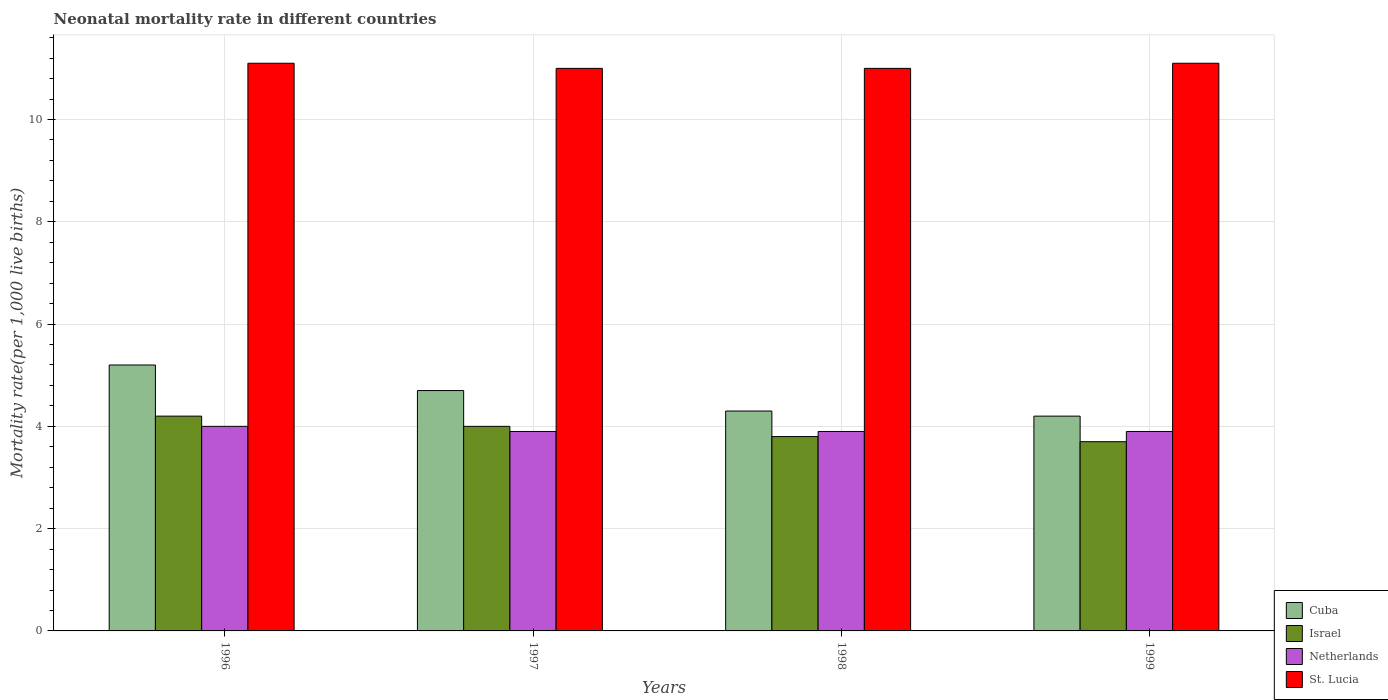How many different coloured bars are there?
Provide a succinct answer. 4. Are the number of bars per tick equal to the number of legend labels?
Keep it short and to the point. Yes. How many bars are there on the 4th tick from the right?
Your answer should be compact. 4. What is the label of the 3rd group of bars from the left?
Your answer should be compact. 1998. In how many cases, is the number of bars for a given year not equal to the number of legend labels?
Make the answer very short. 0. What is the neonatal mortality rate in Netherlands in 1996?
Offer a terse response. 4. Across all years, what is the maximum neonatal mortality rate in St. Lucia?
Your answer should be compact. 11.1. What is the total neonatal mortality rate in Cuba in the graph?
Offer a very short reply. 18.4. What is the difference between the neonatal mortality rate in Netherlands in 1996 and that in 1997?
Give a very brief answer. 0.1. What is the difference between the neonatal mortality rate in Netherlands in 1997 and the neonatal mortality rate in Israel in 1996?
Offer a terse response. -0.3. What is the average neonatal mortality rate in St. Lucia per year?
Your answer should be very brief. 11.05. In the year 1998, what is the difference between the neonatal mortality rate in St. Lucia and neonatal mortality rate in Cuba?
Make the answer very short. 6.7. In how many years, is the neonatal mortality rate in Cuba greater than 6.4?
Offer a very short reply. 0. What is the ratio of the neonatal mortality rate in St. Lucia in 1996 to that in 1999?
Keep it short and to the point. 1. Is the neonatal mortality rate in Cuba in 1997 less than that in 1998?
Your answer should be compact. No. What is the difference between the highest and the second highest neonatal mortality rate in Cuba?
Your answer should be very brief. 0.5. What is the difference between the highest and the lowest neonatal mortality rate in Cuba?
Offer a very short reply. 1. In how many years, is the neonatal mortality rate in Netherlands greater than the average neonatal mortality rate in Netherlands taken over all years?
Give a very brief answer. 1. Is the sum of the neonatal mortality rate in Cuba in 1997 and 1998 greater than the maximum neonatal mortality rate in Netherlands across all years?
Your answer should be very brief. Yes. What does the 4th bar from the left in 1998 represents?
Your response must be concise. St. Lucia. What does the 4th bar from the right in 1999 represents?
Provide a succinct answer. Cuba. Is it the case that in every year, the sum of the neonatal mortality rate in Israel and neonatal mortality rate in Cuba is greater than the neonatal mortality rate in Netherlands?
Give a very brief answer. Yes. What is the difference between two consecutive major ticks on the Y-axis?
Provide a succinct answer. 2. Does the graph contain any zero values?
Provide a short and direct response. No. Where does the legend appear in the graph?
Offer a very short reply. Bottom right. What is the title of the graph?
Provide a succinct answer. Neonatal mortality rate in different countries. Does "Singapore" appear as one of the legend labels in the graph?
Make the answer very short. No. What is the label or title of the Y-axis?
Give a very brief answer. Mortality rate(per 1,0 live births). What is the Mortality rate(per 1,000 live births) of Netherlands in 1996?
Offer a very short reply. 4. What is the Mortality rate(per 1,000 live births) of St. Lucia in 1996?
Give a very brief answer. 11.1. What is the Mortality rate(per 1,000 live births) of Cuba in 1997?
Offer a very short reply. 4.7. What is the Mortality rate(per 1,000 live births) in Israel in 1997?
Offer a terse response. 4. What is the Mortality rate(per 1,000 live births) of St. Lucia in 1997?
Offer a very short reply. 11. What is the Mortality rate(per 1,000 live births) in Cuba in 1998?
Offer a terse response. 4.3. What is the Mortality rate(per 1,000 live births) of Israel in 1998?
Provide a short and direct response. 3.8. What is the Mortality rate(per 1,000 live births) of Netherlands in 1998?
Offer a very short reply. 3.9. What is the Mortality rate(per 1,000 live births) of St. Lucia in 1998?
Your response must be concise. 11. What is the Mortality rate(per 1,000 live births) of Cuba in 1999?
Make the answer very short. 4.2. What is the Mortality rate(per 1,000 live births) in St. Lucia in 1999?
Make the answer very short. 11.1. Across all years, what is the maximum Mortality rate(per 1,000 live births) in Cuba?
Offer a terse response. 5.2. Across all years, what is the minimum Mortality rate(per 1,000 live births) in Cuba?
Provide a short and direct response. 4.2. Across all years, what is the minimum Mortality rate(per 1,000 live births) in Netherlands?
Your answer should be very brief. 3.9. Across all years, what is the minimum Mortality rate(per 1,000 live births) of St. Lucia?
Provide a succinct answer. 11. What is the total Mortality rate(per 1,000 live births) of Cuba in the graph?
Make the answer very short. 18.4. What is the total Mortality rate(per 1,000 live births) of Israel in the graph?
Your response must be concise. 15.7. What is the total Mortality rate(per 1,000 live births) of Netherlands in the graph?
Your answer should be compact. 15.7. What is the total Mortality rate(per 1,000 live births) in St. Lucia in the graph?
Make the answer very short. 44.2. What is the difference between the Mortality rate(per 1,000 live births) in Netherlands in 1996 and that in 1997?
Offer a terse response. 0.1. What is the difference between the Mortality rate(per 1,000 live births) in Cuba in 1996 and that in 1998?
Your response must be concise. 0.9. What is the difference between the Mortality rate(per 1,000 live births) in Israel in 1996 and that in 1998?
Give a very brief answer. 0.4. What is the difference between the Mortality rate(per 1,000 live births) of Netherlands in 1996 and that in 1998?
Provide a short and direct response. 0.1. What is the difference between the Mortality rate(per 1,000 live births) in St. Lucia in 1996 and that in 1998?
Provide a short and direct response. 0.1. What is the difference between the Mortality rate(per 1,000 live births) of Cuba in 1996 and that in 1999?
Offer a very short reply. 1. What is the difference between the Mortality rate(per 1,000 live births) of Netherlands in 1996 and that in 1999?
Make the answer very short. 0.1. What is the difference between the Mortality rate(per 1,000 live births) in St. Lucia in 1996 and that in 1999?
Ensure brevity in your answer.  0. What is the difference between the Mortality rate(per 1,000 live births) in Cuba in 1997 and that in 1998?
Keep it short and to the point. 0.4. What is the difference between the Mortality rate(per 1,000 live births) in St. Lucia in 1997 and that in 1998?
Provide a short and direct response. 0. What is the difference between the Mortality rate(per 1,000 live births) in Cuba in 1997 and that in 1999?
Offer a very short reply. 0.5. What is the difference between the Mortality rate(per 1,000 live births) of Netherlands in 1997 and that in 1999?
Give a very brief answer. 0. What is the difference between the Mortality rate(per 1,000 live births) of Cuba in 1998 and that in 1999?
Ensure brevity in your answer.  0.1. What is the difference between the Mortality rate(per 1,000 live births) of Israel in 1998 and that in 1999?
Offer a terse response. 0.1. What is the difference between the Mortality rate(per 1,000 live births) in Netherlands in 1998 and that in 1999?
Provide a short and direct response. 0. What is the difference between the Mortality rate(per 1,000 live births) in Israel in 1996 and the Mortality rate(per 1,000 live births) in Netherlands in 1997?
Your answer should be very brief. 0.3. What is the difference between the Mortality rate(per 1,000 live births) in Israel in 1996 and the Mortality rate(per 1,000 live births) in St. Lucia in 1997?
Provide a short and direct response. -6.8. What is the difference between the Mortality rate(per 1,000 live births) in Cuba in 1996 and the Mortality rate(per 1,000 live births) in Israel in 1998?
Make the answer very short. 1.4. What is the difference between the Mortality rate(per 1,000 live births) in Cuba in 1996 and the Mortality rate(per 1,000 live births) in St. Lucia in 1998?
Offer a terse response. -5.8. What is the difference between the Mortality rate(per 1,000 live births) in Israel in 1996 and the Mortality rate(per 1,000 live births) in Netherlands in 1998?
Offer a very short reply. 0.3. What is the difference between the Mortality rate(per 1,000 live births) in Israel in 1996 and the Mortality rate(per 1,000 live births) in St. Lucia in 1998?
Provide a short and direct response. -6.8. What is the difference between the Mortality rate(per 1,000 live births) of Netherlands in 1996 and the Mortality rate(per 1,000 live births) of St. Lucia in 1998?
Offer a terse response. -7. What is the difference between the Mortality rate(per 1,000 live births) in Cuba in 1996 and the Mortality rate(per 1,000 live births) in Netherlands in 1999?
Offer a terse response. 1.3. What is the difference between the Mortality rate(per 1,000 live births) in Cuba in 1996 and the Mortality rate(per 1,000 live births) in St. Lucia in 1999?
Ensure brevity in your answer.  -5.9. What is the difference between the Mortality rate(per 1,000 live births) of Israel in 1996 and the Mortality rate(per 1,000 live births) of Netherlands in 1999?
Give a very brief answer. 0.3. What is the difference between the Mortality rate(per 1,000 live births) of Israel in 1996 and the Mortality rate(per 1,000 live births) of St. Lucia in 1999?
Your response must be concise. -6.9. What is the difference between the Mortality rate(per 1,000 live births) of Cuba in 1997 and the Mortality rate(per 1,000 live births) of Israel in 1998?
Offer a very short reply. 0.9. What is the difference between the Mortality rate(per 1,000 live births) of Cuba in 1997 and the Mortality rate(per 1,000 live births) of St. Lucia in 1998?
Keep it short and to the point. -6.3. What is the difference between the Mortality rate(per 1,000 live births) of Israel in 1997 and the Mortality rate(per 1,000 live births) of St. Lucia in 1998?
Provide a succinct answer. -7. What is the difference between the Mortality rate(per 1,000 live births) in Cuba in 1997 and the Mortality rate(per 1,000 live births) in Israel in 1999?
Offer a very short reply. 1. What is the difference between the Mortality rate(per 1,000 live births) in Cuba in 1997 and the Mortality rate(per 1,000 live births) in Netherlands in 1999?
Your response must be concise. 0.8. What is the difference between the Mortality rate(per 1,000 live births) of Cuba in 1997 and the Mortality rate(per 1,000 live births) of St. Lucia in 1999?
Offer a very short reply. -6.4. What is the difference between the Mortality rate(per 1,000 live births) of Israel in 1997 and the Mortality rate(per 1,000 live births) of Netherlands in 1999?
Your answer should be very brief. 0.1. What is the difference between the Mortality rate(per 1,000 live births) of Cuba in 1998 and the Mortality rate(per 1,000 live births) of Israel in 1999?
Offer a terse response. 0.6. What is the difference between the Mortality rate(per 1,000 live births) of Cuba in 1998 and the Mortality rate(per 1,000 live births) of St. Lucia in 1999?
Make the answer very short. -6.8. What is the difference between the Mortality rate(per 1,000 live births) in Israel in 1998 and the Mortality rate(per 1,000 live births) in St. Lucia in 1999?
Give a very brief answer. -7.3. What is the average Mortality rate(per 1,000 live births) in Israel per year?
Ensure brevity in your answer.  3.92. What is the average Mortality rate(per 1,000 live births) of Netherlands per year?
Your answer should be very brief. 3.92. What is the average Mortality rate(per 1,000 live births) in St. Lucia per year?
Make the answer very short. 11.05. In the year 1996, what is the difference between the Mortality rate(per 1,000 live births) of Cuba and Mortality rate(per 1,000 live births) of Israel?
Offer a terse response. 1. In the year 1996, what is the difference between the Mortality rate(per 1,000 live births) of Cuba and Mortality rate(per 1,000 live births) of Netherlands?
Keep it short and to the point. 1.2. In the year 1996, what is the difference between the Mortality rate(per 1,000 live births) in Cuba and Mortality rate(per 1,000 live births) in St. Lucia?
Provide a succinct answer. -5.9. In the year 1996, what is the difference between the Mortality rate(per 1,000 live births) in Israel and Mortality rate(per 1,000 live births) in Netherlands?
Your answer should be very brief. 0.2. In the year 1996, what is the difference between the Mortality rate(per 1,000 live births) in Israel and Mortality rate(per 1,000 live births) in St. Lucia?
Your answer should be compact. -6.9. In the year 1996, what is the difference between the Mortality rate(per 1,000 live births) in Netherlands and Mortality rate(per 1,000 live births) in St. Lucia?
Keep it short and to the point. -7.1. In the year 1997, what is the difference between the Mortality rate(per 1,000 live births) in Cuba and Mortality rate(per 1,000 live births) in Israel?
Your answer should be compact. 0.7. In the year 1997, what is the difference between the Mortality rate(per 1,000 live births) of Cuba and Mortality rate(per 1,000 live births) of Netherlands?
Keep it short and to the point. 0.8. In the year 1997, what is the difference between the Mortality rate(per 1,000 live births) in Cuba and Mortality rate(per 1,000 live births) in St. Lucia?
Keep it short and to the point. -6.3. In the year 1997, what is the difference between the Mortality rate(per 1,000 live births) of Israel and Mortality rate(per 1,000 live births) of Netherlands?
Keep it short and to the point. 0.1. In the year 1997, what is the difference between the Mortality rate(per 1,000 live births) of Israel and Mortality rate(per 1,000 live births) of St. Lucia?
Your answer should be very brief. -7. In the year 1997, what is the difference between the Mortality rate(per 1,000 live births) of Netherlands and Mortality rate(per 1,000 live births) of St. Lucia?
Provide a succinct answer. -7.1. In the year 1998, what is the difference between the Mortality rate(per 1,000 live births) in Cuba and Mortality rate(per 1,000 live births) in Netherlands?
Your answer should be compact. 0.4. In the year 1998, what is the difference between the Mortality rate(per 1,000 live births) in Israel and Mortality rate(per 1,000 live births) in Netherlands?
Provide a short and direct response. -0.1. In the year 1998, what is the difference between the Mortality rate(per 1,000 live births) in Israel and Mortality rate(per 1,000 live births) in St. Lucia?
Your answer should be compact. -7.2. In the year 1999, what is the difference between the Mortality rate(per 1,000 live births) of Cuba and Mortality rate(per 1,000 live births) of Israel?
Offer a very short reply. 0.5. In the year 1999, what is the difference between the Mortality rate(per 1,000 live births) of Cuba and Mortality rate(per 1,000 live births) of Netherlands?
Make the answer very short. 0.3. In the year 1999, what is the difference between the Mortality rate(per 1,000 live births) of Cuba and Mortality rate(per 1,000 live births) of St. Lucia?
Offer a terse response. -6.9. What is the ratio of the Mortality rate(per 1,000 live births) in Cuba in 1996 to that in 1997?
Offer a very short reply. 1.11. What is the ratio of the Mortality rate(per 1,000 live births) of Israel in 1996 to that in 1997?
Keep it short and to the point. 1.05. What is the ratio of the Mortality rate(per 1,000 live births) of Netherlands in 1996 to that in 1997?
Make the answer very short. 1.03. What is the ratio of the Mortality rate(per 1,000 live births) of St. Lucia in 1996 to that in 1997?
Make the answer very short. 1.01. What is the ratio of the Mortality rate(per 1,000 live births) in Cuba in 1996 to that in 1998?
Keep it short and to the point. 1.21. What is the ratio of the Mortality rate(per 1,000 live births) of Israel in 1996 to that in 1998?
Your answer should be compact. 1.11. What is the ratio of the Mortality rate(per 1,000 live births) in Netherlands in 1996 to that in 1998?
Keep it short and to the point. 1.03. What is the ratio of the Mortality rate(per 1,000 live births) in St. Lucia in 1996 to that in 1998?
Your answer should be very brief. 1.01. What is the ratio of the Mortality rate(per 1,000 live births) of Cuba in 1996 to that in 1999?
Offer a terse response. 1.24. What is the ratio of the Mortality rate(per 1,000 live births) of Israel in 1996 to that in 1999?
Ensure brevity in your answer.  1.14. What is the ratio of the Mortality rate(per 1,000 live births) in Netherlands in 1996 to that in 1999?
Provide a succinct answer. 1.03. What is the ratio of the Mortality rate(per 1,000 live births) in Cuba in 1997 to that in 1998?
Give a very brief answer. 1.09. What is the ratio of the Mortality rate(per 1,000 live births) of Israel in 1997 to that in 1998?
Keep it short and to the point. 1.05. What is the ratio of the Mortality rate(per 1,000 live births) of Netherlands in 1997 to that in 1998?
Ensure brevity in your answer.  1. What is the ratio of the Mortality rate(per 1,000 live births) in Cuba in 1997 to that in 1999?
Provide a short and direct response. 1.12. What is the ratio of the Mortality rate(per 1,000 live births) in Israel in 1997 to that in 1999?
Provide a succinct answer. 1.08. What is the ratio of the Mortality rate(per 1,000 live births) in Cuba in 1998 to that in 1999?
Offer a very short reply. 1.02. What is the ratio of the Mortality rate(per 1,000 live births) of Israel in 1998 to that in 1999?
Provide a succinct answer. 1.03. What is the ratio of the Mortality rate(per 1,000 live births) in Netherlands in 1998 to that in 1999?
Your response must be concise. 1. What is the difference between the highest and the second highest Mortality rate(per 1,000 live births) in St. Lucia?
Give a very brief answer. 0. What is the difference between the highest and the lowest Mortality rate(per 1,000 live births) of Cuba?
Offer a very short reply. 1. What is the difference between the highest and the lowest Mortality rate(per 1,000 live births) of Israel?
Make the answer very short. 0.5. What is the difference between the highest and the lowest Mortality rate(per 1,000 live births) of St. Lucia?
Offer a terse response. 0.1. 